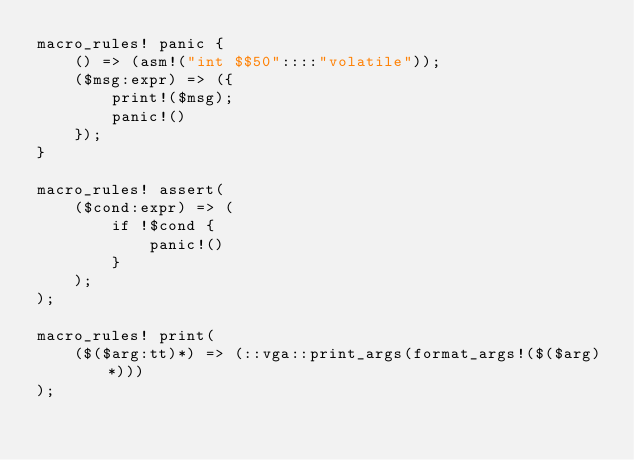Convert code to text. <code><loc_0><loc_0><loc_500><loc_500><_Rust_>macro_rules! panic {
    () => (asm!("int $$50"::::"volatile"));
    ($msg:expr) => ({
        print!($msg);
        panic!()
    });
}

macro_rules! assert(
    ($cond:expr) => (
        if !$cond {
            panic!()
        }
    );
);

macro_rules! print(
    ($($arg:tt)*) => (::vga::print_args(format_args!($($arg)*)))
);</code> 